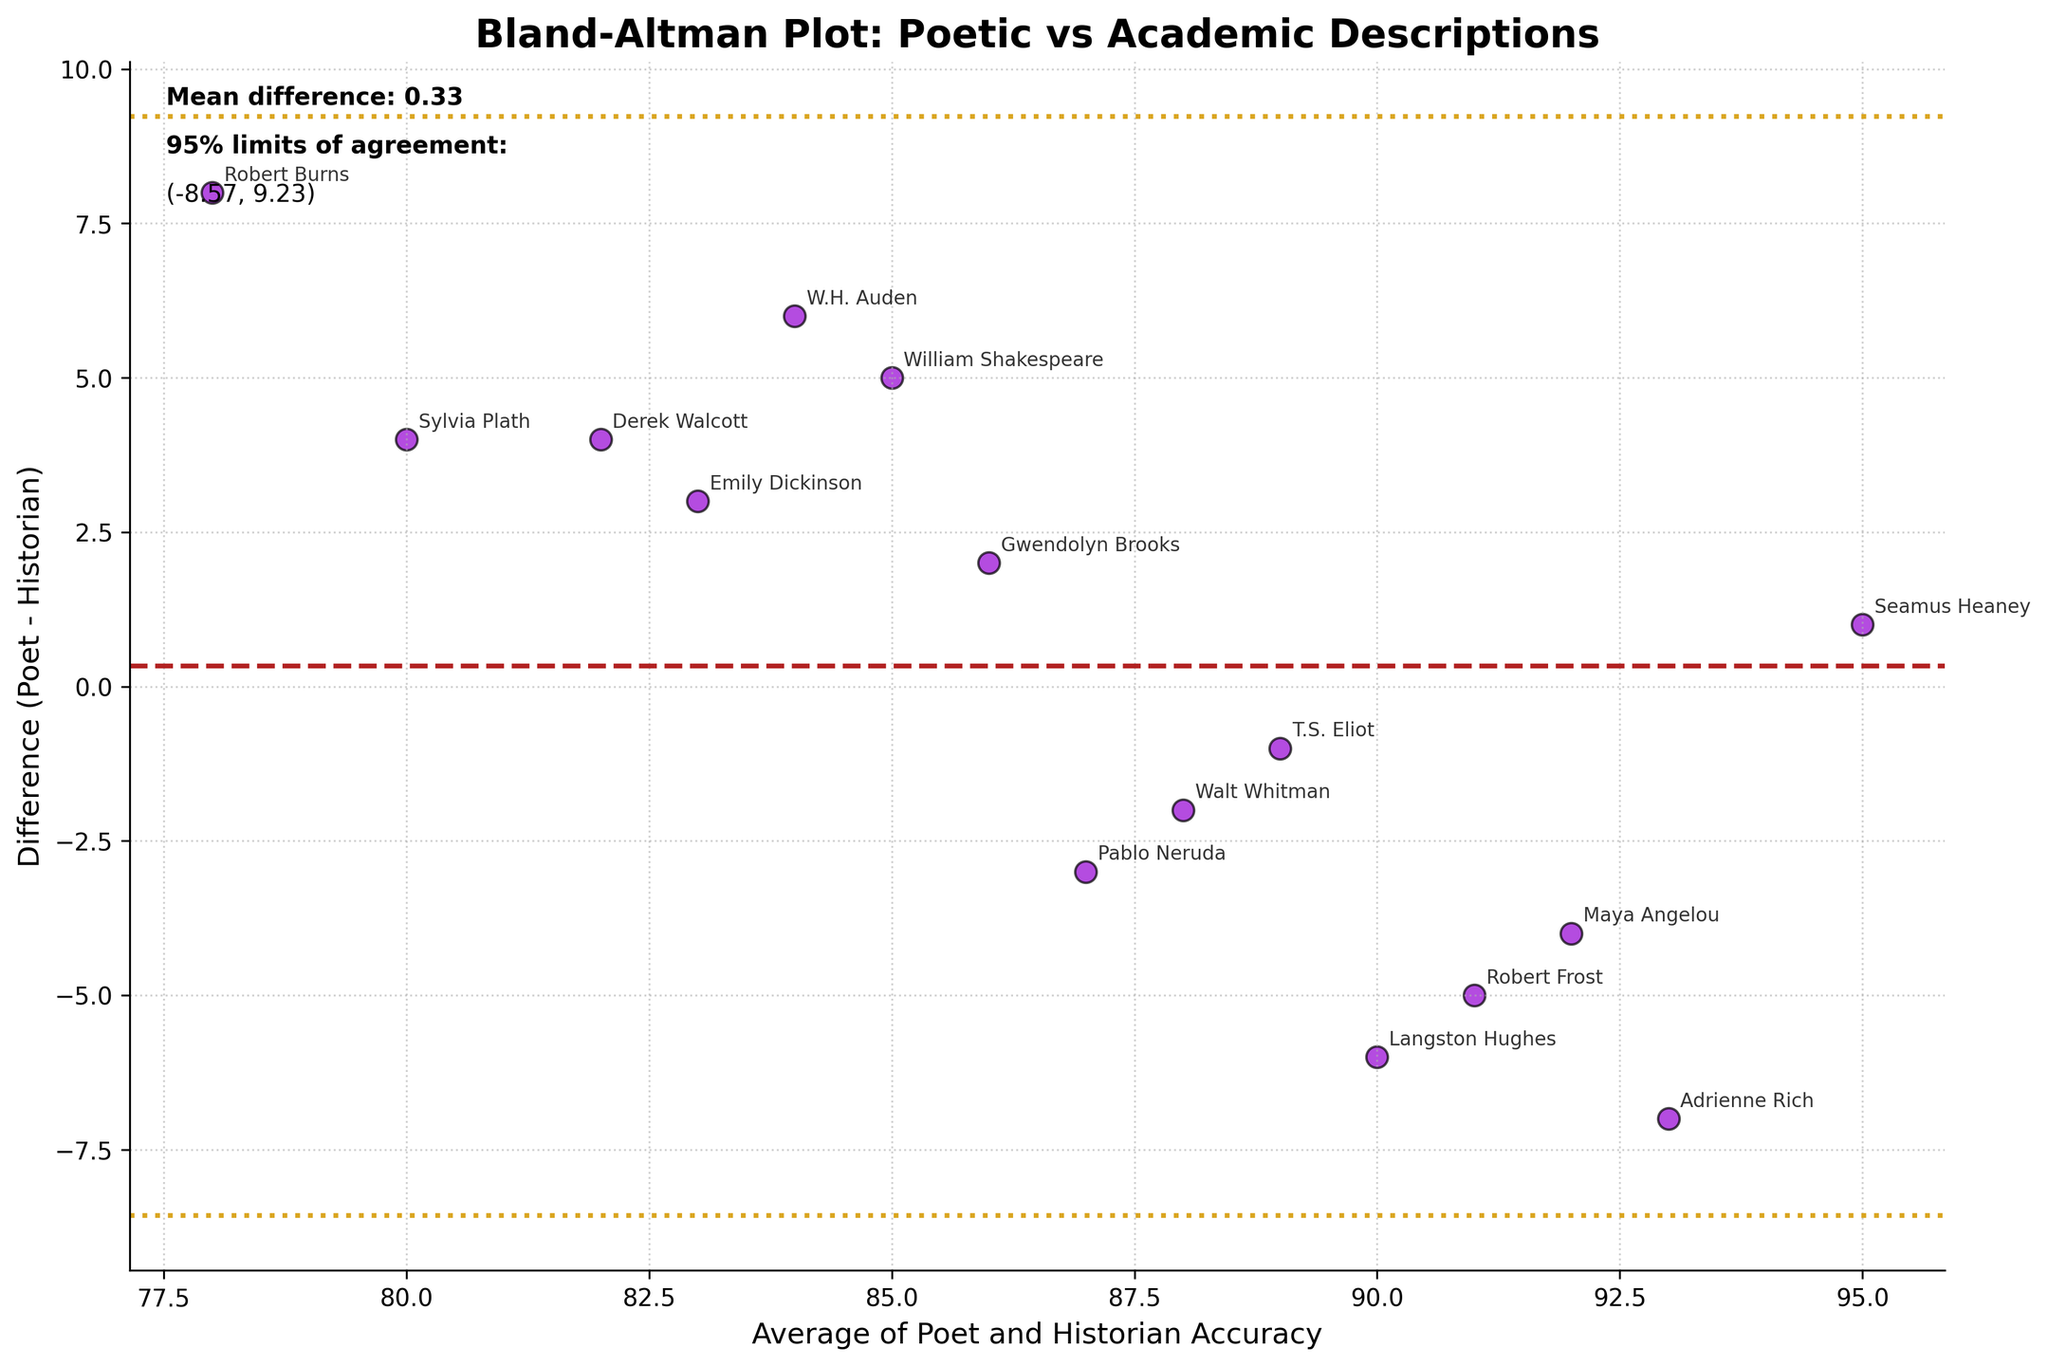What's the title of the plot? The title of the plot is shown at the top of the figure. It reads "Bland-Altman Plot: Poetic vs Academic Descriptions"
Answer: Bland-Altman Plot: Poetic vs Academic Descriptions How many data points are plotted? Each point corresponds to a poet and a historian pair. By counting the number of labeled points in the figure, we see there are 15 data points.
Answer: 15 What is the color of the points on the plot? The color of the points can be observed as darkviolet from the figure description. This color stands out against the background and is uniform for all points.
Answer: Darkviolet What's the mean difference between the poets' and historians' accuracies? The mean difference is indicated by a horizontal line and is also written at the top left of the plot as "Mean difference: -0.87".
Answer: -0.87 What are the 95% limits of agreement? The 95% limits of agreement are marked by goldenrod-colored horizontal lines and also listed in the figure as (-6.96, 5.22). These limits are calculated as the mean difference plus or minus 1.96 times the standard deviation of the differences.
Answer: (-6.96, 5.22) Which poet-historian pair has the largest difference? By looking for the point furthest from the mean difference line, we see that Robert Burns (78, 8) and Adrienne Rich (93, -7) have the highest differences. Comparing their vertical distances, Adrienne Rich has the largest magnitude of difference.
Answer: Adrienne Rich and Nancy F. Cott Which poet-historian pair is closest to having equal accuracy? Points closest to the horizontal line at 0 have the smallest difference. Seamus Heaney (95, 1) is the closest to the line and thus closest to equal accuracy.
Answer: Seamus Heaney and Roy Foster How many poet-historian pairs fall within the 95% limits of agreement? By counting the data points that lie between the horizontal lines at -6.96 and 5.22, we determine that 13 out of the 15 data points fall within these limits.
Answer: 13 Which poet-historian pair has the lowest average accuracy? The average accuracy is plotted on the x-axis, and by identifying the point farthest to the left, we see Robert Burns (78) has the lowest average accuracy.
Answer: Robert Burns and Thomas Carlyle Is there any apparent bias in the poetic descriptions compared to academic biographies? The mean difference line is slightly below zero (-0.87), which indicates a small bias where poets' accuracy tends to be slightly underestimated compared to historians'.
Answer: Yes, there is a slight bias 